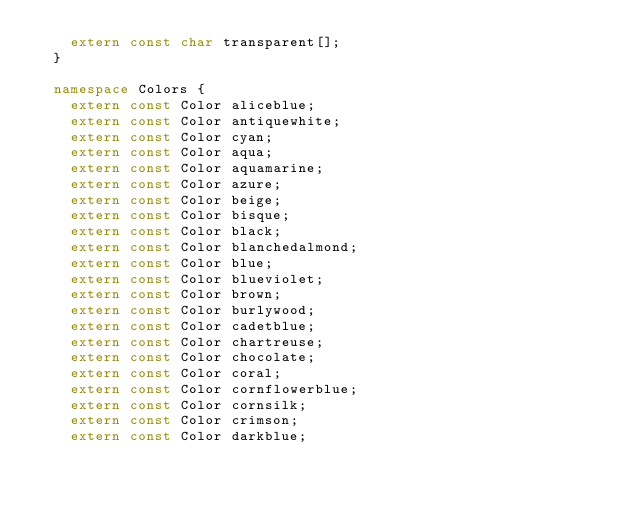<code> <loc_0><loc_0><loc_500><loc_500><_C++_>    extern const char transparent[];
  }

  namespace Colors {
    extern const Color aliceblue;
    extern const Color antiquewhite;
    extern const Color cyan;
    extern const Color aqua;
    extern const Color aquamarine;
    extern const Color azure;
    extern const Color beige;
    extern const Color bisque;
    extern const Color black;
    extern const Color blanchedalmond;
    extern const Color blue;
    extern const Color blueviolet;
    extern const Color brown;
    extern const Color burlywood;
    extern const Color cadetblue;
    extern const Color chartreuse;
    extern const Color chocolate;
    extern const Color coral;
    extern const Color cornflowerblue;
    extern const Color cornsilk;
    extern const Color crimson;
    extern const Color darkblue;</code> 